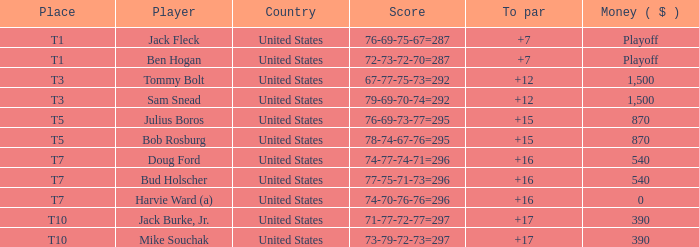What is the average score relative to par for bud holscher as a player? 16.0. 